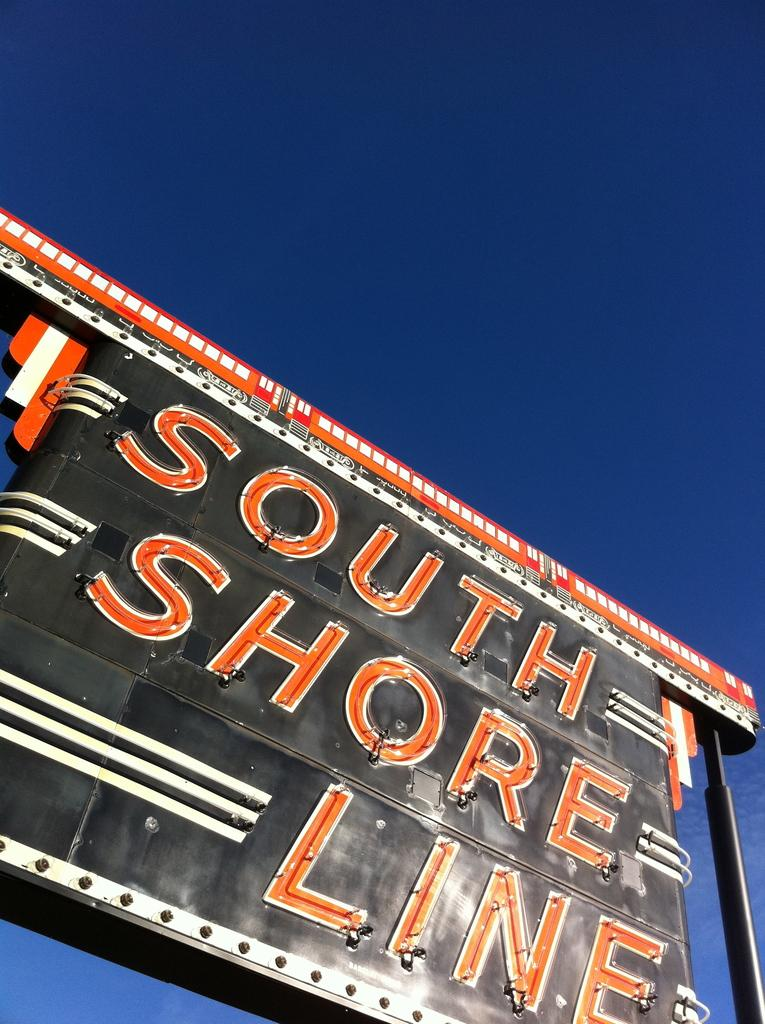<image>
Render a clear and concise summary of the photo. Black, white, and orange South Shore Line sign. 